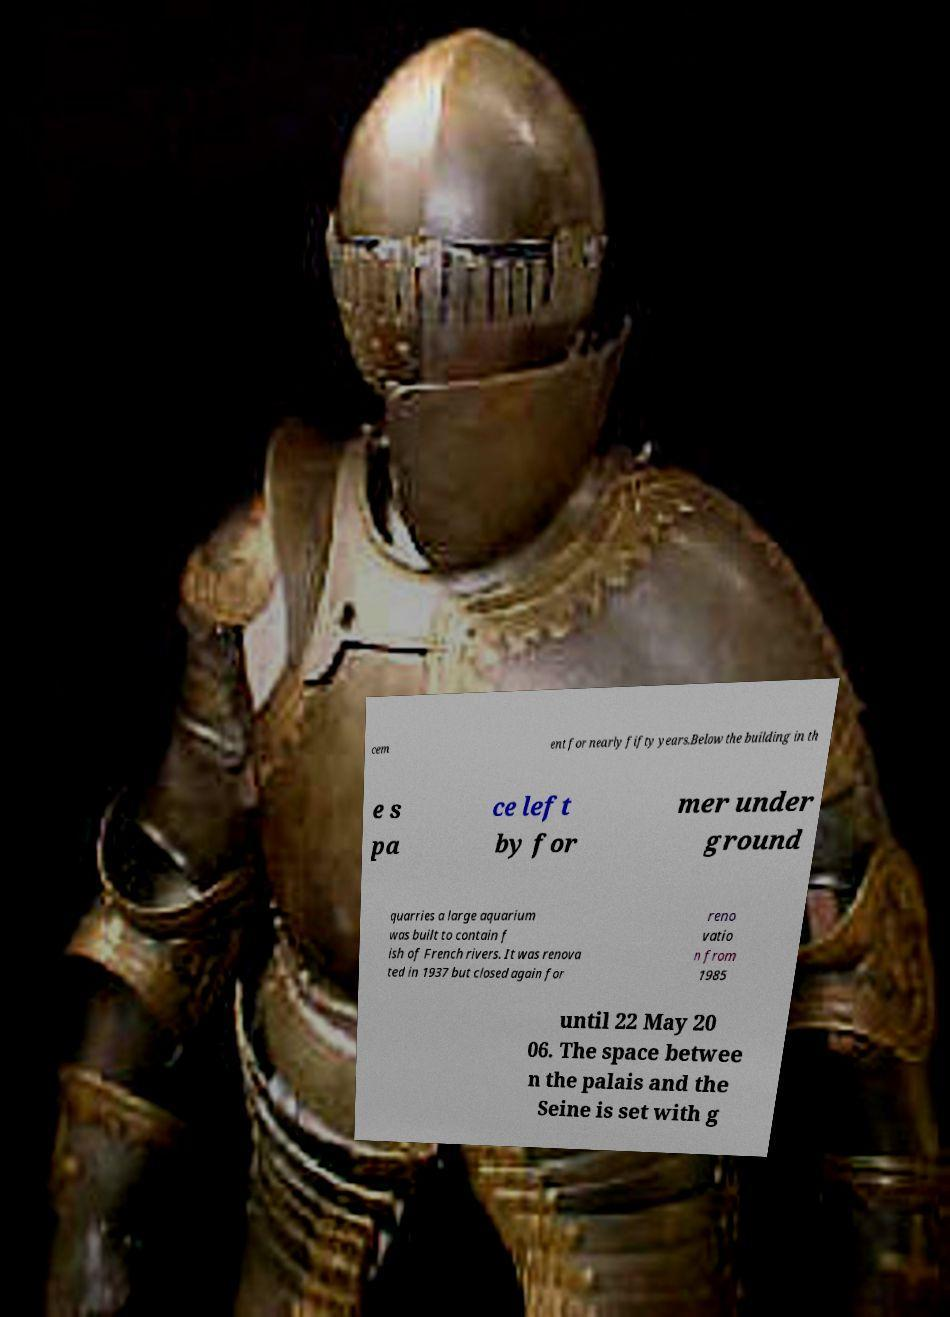Can you accurately transcribe the text from the provided image for me? cem ent for nearly fifty years.Below the building in th e s pa ce left by for mer under ground quarries a large aquarium was built to contain f ish of French rivers. It was renova ted in 1937 but closed again for reno vatio n from 1985 until 22 May 20 06. The space betwee n the palais and the Seine is set with g 